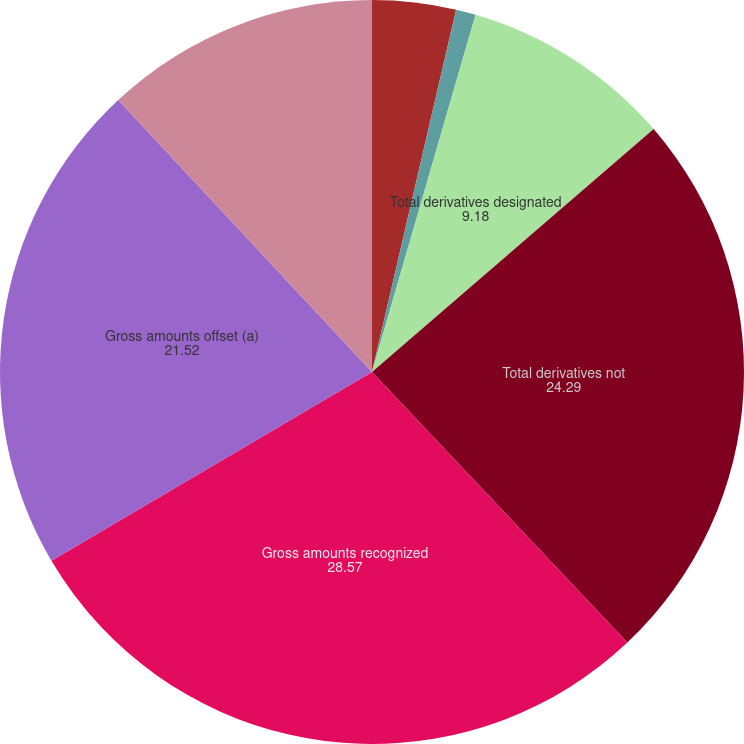Convert chart to OTSL. <chart><loc_0><loc_0><loc_500><loc_500><pie_chart><fcel>Other current assets/Other<fcel>Other deferred charges and<fcel>Total derivatives designated<fcel>Total derivatives not<fcel>Gross amounts recognized<fcel>Gross amounts offset (a)<fcel>Net amounts recognized in the<nl><fcel>3.63%<fcel>0.86%<fcel>9.18%<fcel>24.29%<fcel>28.57%<fcel>21.52%<fcel>11.95%<nl></chart> 